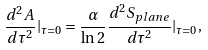<formula> <loc_0><loc_0><loc_500><loc_500>\frac { d ^ { 2 } A } { d \tau ^ { 2 } } | _ { \tau = 0 } = \frac { \alpha } { \ln 2 } \frac { d ^ { 2 } S _ { p l a n e } } { d \tau ^ { 2 } } | _ { \tau = 0 } ,</formula> 